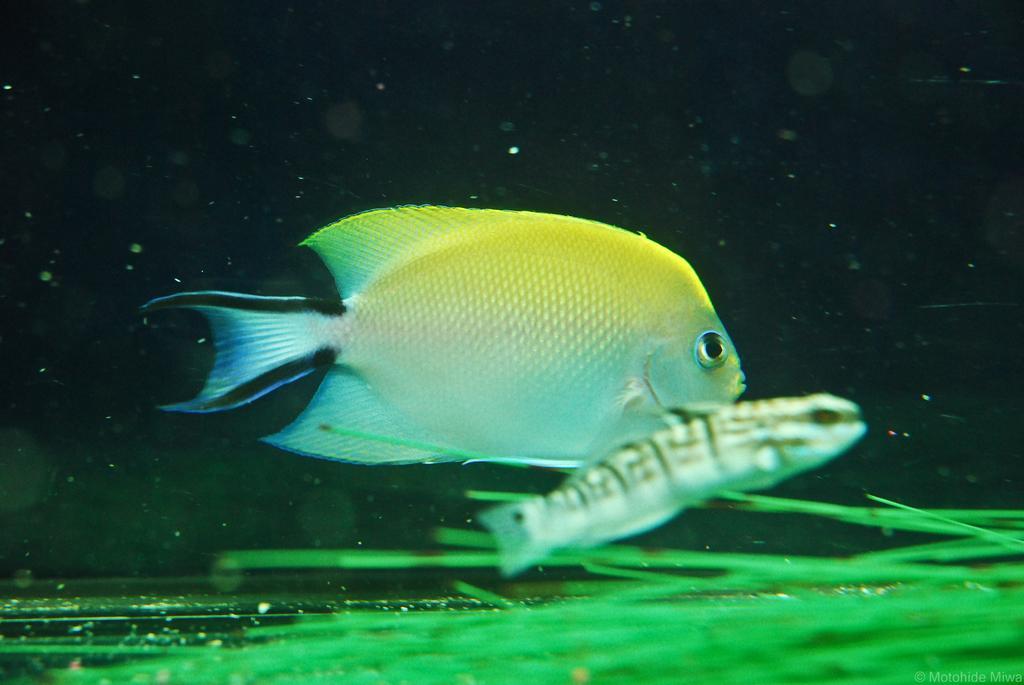How would you summarize this image in a sentence or two? In the given image i can see a fishes and greenery. 